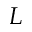<formula> <loc_0><loc_0><loc_500><loc_500>L</formula> 